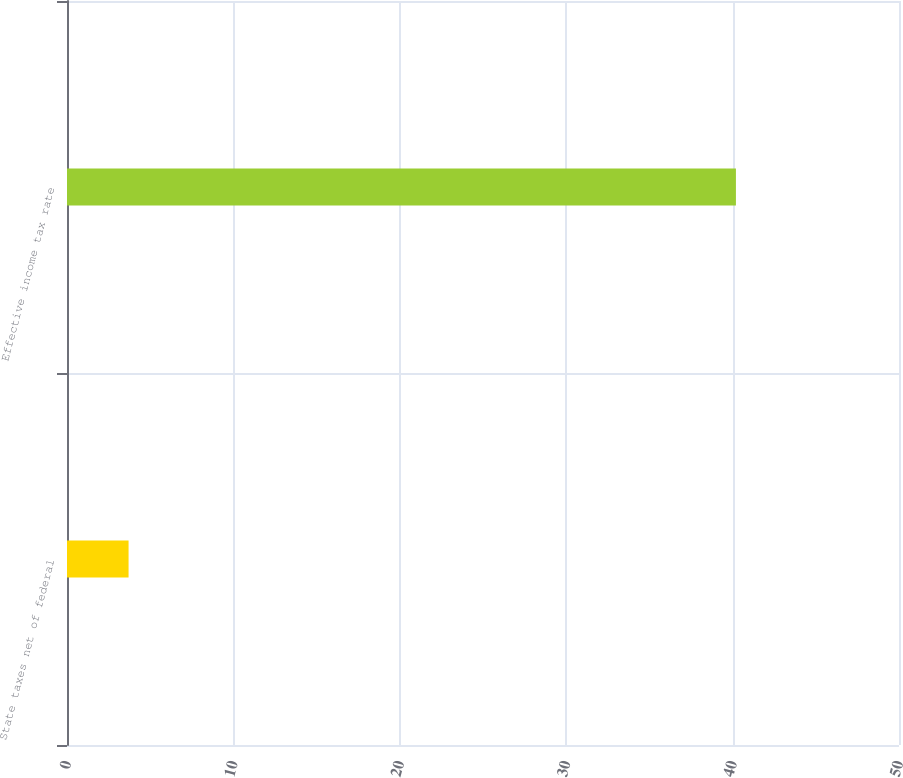<chart> <loc_0><loc_0><loc_500><loc_500><bar_chart><fcel>State taxes net of federal<fcel>Effective income tax rate<nl><fcel>3.7<fcel>40.2<nl></chart> 